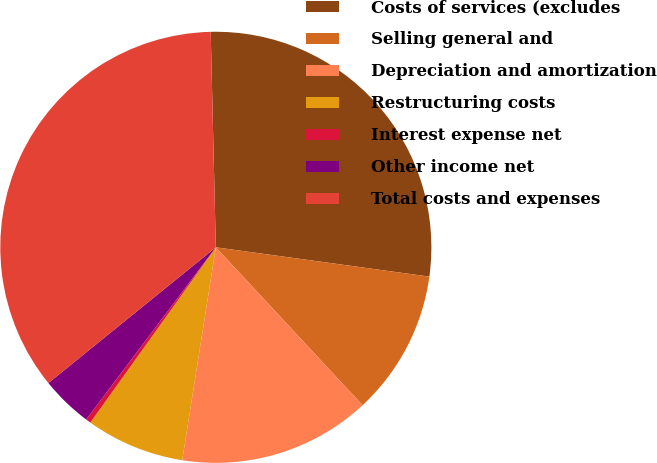Convert chart. <chart><loc_0><loc_0><loc_500><loc_500><pie_chart><fcel>Costs of services (excludes<fcel>Selling general and<fcel>Depreciation and amortization<fcel>Restructuring costs<fcel>Interest expense net<fcel>Other income net<fcel>Total costs and expenses<nl><fcel>27.55%<fcel>10.91%<fcel>14.41%<fcel>7.4%<fcel>0.38%<fcel>3.89%<fcel>35.46%<nl></chart> 